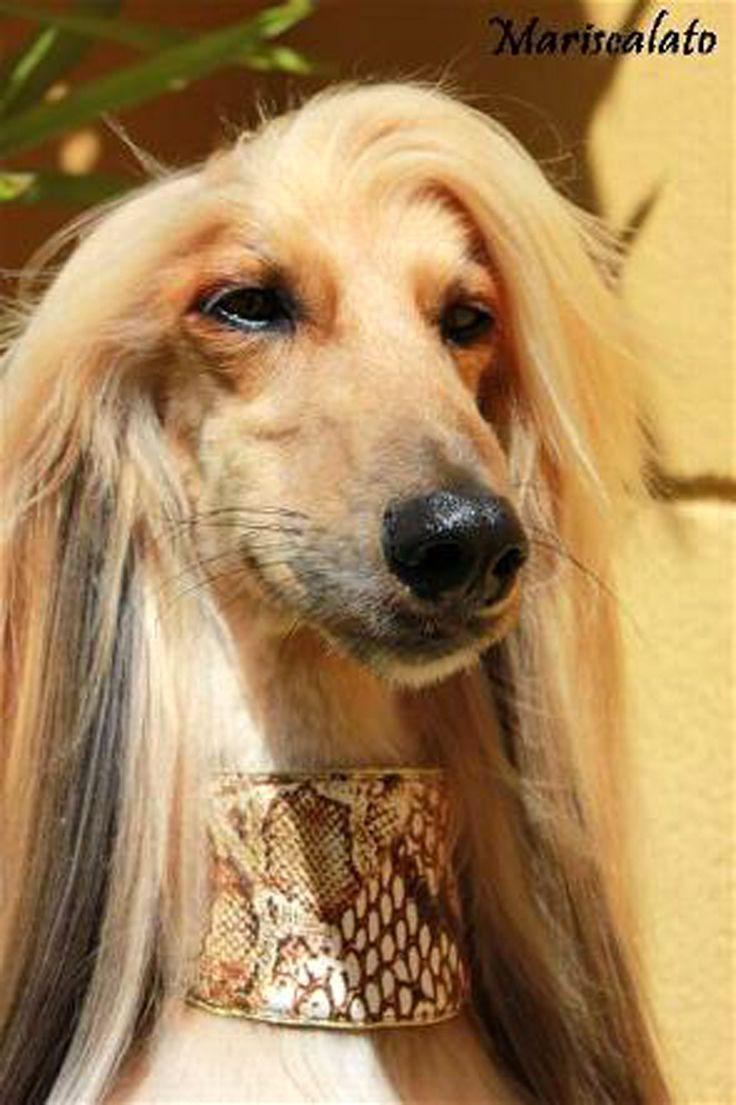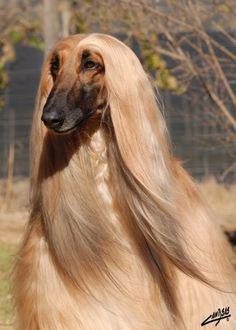The first image is the image on the left, the second image is the image on the right. Assess this claim about the two images: "A dog is wearing something around its neck.". Correct or not? Answer yes or no. Yes. The first image is the image on the left, the second image is the image on the right. Given the left and right images, does the statement "The dog on the left has its muzzle pointing slightly rightward, and the dog on the right has a darker muzzle that the rest of its fur or the dog on the left." hold true? Answer yes or no. Yes. 